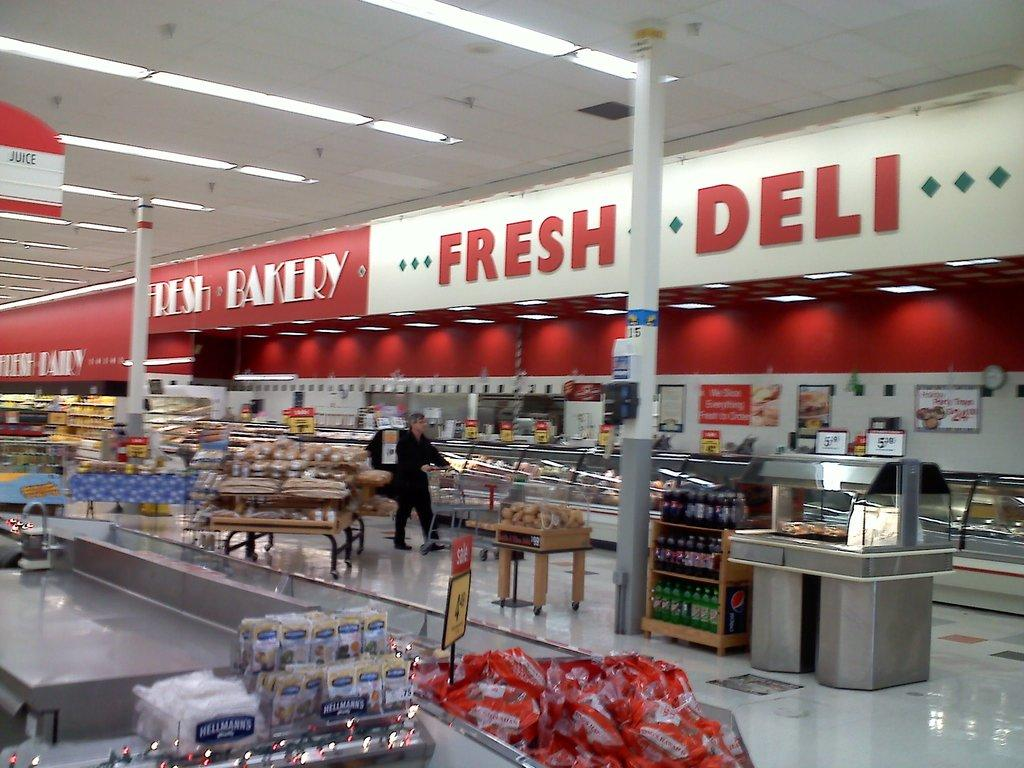<image>
Write a terse but informative summary of the picture. The inside of a grocery store that shows the fresh bakery and fresh deli 